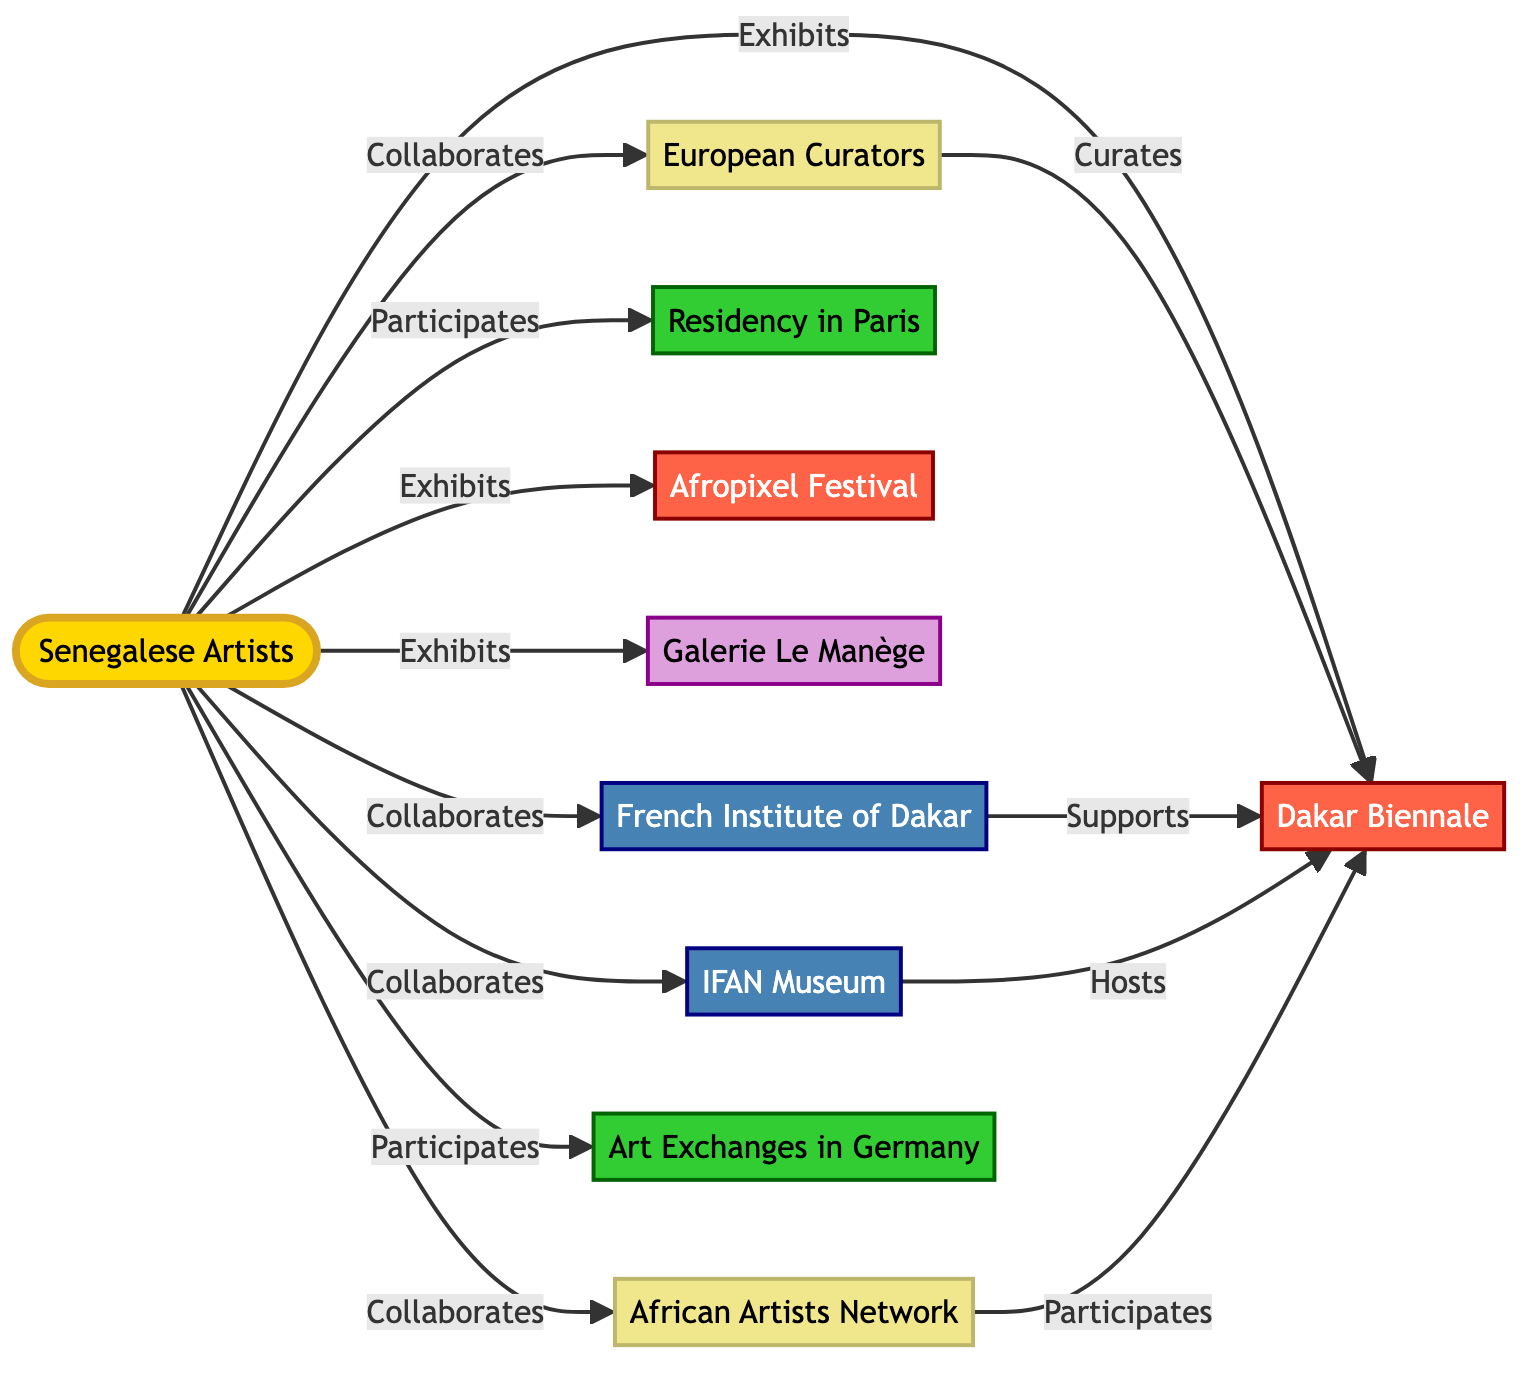What is the central node in the diagram? The central node, which is the main focus of the network, is "Senegalese Artists." This can be found at the center of the diagram, connecting to various other nodes that represent institutions, events, galleries, and collaborations.
Answer: Senegalese Artists How many events are present in the diagram? Looking at the nodes categorized as events, we can see "Dakar Biennale," "Afropixel Festival," which totals two events. This count is derived from counting the nodes labeled as "Event."
Answer: 2 What type of relationship exists between "Senegalese Artists" and "Dakar Biennale"? The relationship, as represented by the arrow connecting these two nodes, is labeled "Exhibits." This indicates that the Senegalese Artists exhibit their work at the Dakar Biennale.
Answer: Exhibits Who supports the "Dakar Biennale"? The "French Institute of Dakar" is shown to support the "Dakar Biennale" through a directed connection labeled "Supports." This indicates a supportive role of the institute toward the event.
Answer: French Institute of Dakar Which collaborators are involved with "Senegalese Artists"? The collaborators linked to "Senegalese Artists" are "European Curators" and "African Artists Network," both identified as connected through a "Collaborates" relationship. Therefore, these are the entities that collaborate with Senegalese Artists.
Answer: European Curators, African Artists Network What program connects Senegalese Artists to international collaborations? "Residency in Paris" is identified as a program where Senegalese Artists participate, suggesting a connection to international collaboration opportunities beyond Senegal. This participation indicates involvement in a more global artistic context.
Answer: Residency in Paris How many nodes are there in total? By counting all unique nodes present in the diagram, which include institutions, events, galleries, programs, and collaborators, the total comes to ten nodes. This indicates the comprehensive structure of connections depicted in the diagram.
Answer: 10 Which gallery is linked with "Senegalese Artists"? The node "Galerie Le Manège" is specifically linked to "Senegalese Artists" with a directed connection labeled "Exhibits." This indicates a relationship where Senegalese Artists exhibit their work at this gallery.
Answer: Galerie Le Manège What is the relationship between "European Curators" and "Dakar Biennale"? The relationship is defined as "Curates," indicating that European Curators have a role in curating exhibits that take place during the Dakar Biennale. This shows their influence in shaping the event's art presentation.
Answer: Curates 